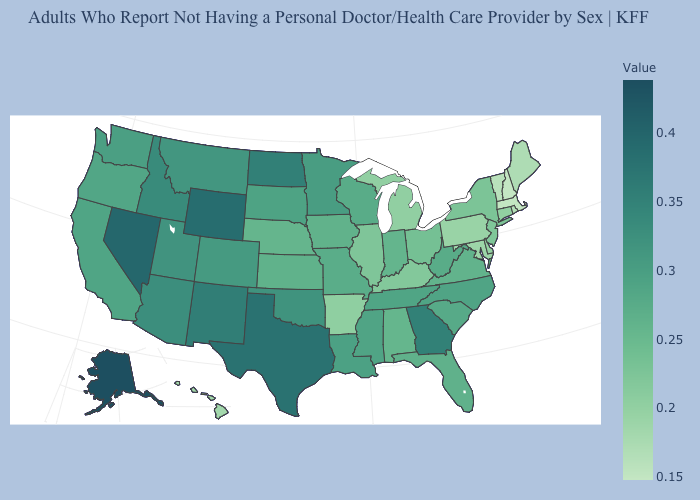Among the states that border Arizona , does California have the lowest value?
Short answer required. Yes. Among the states that border Ohio , which have the lowest value?
Answer briefly. Pennsylvania. Does North Carolina have a lower value than Delaware?
Keep it brief. No. Does Virginia have the lowest value in the South?
Give a very brief answer. No. Which states have the highest value in the USA?
Answer briefly. Alaska. Which states have the highest value in the USA?
Quick response, please. Alaska. 